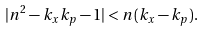Convert formula to latex. <formula><loc_0><loc_0><loc_500><loc_500>| n ^ { 2 } - k _ { x } k _ { p } - 1 | < n ( k _ { x } - k _ { p } ) .</formula> 